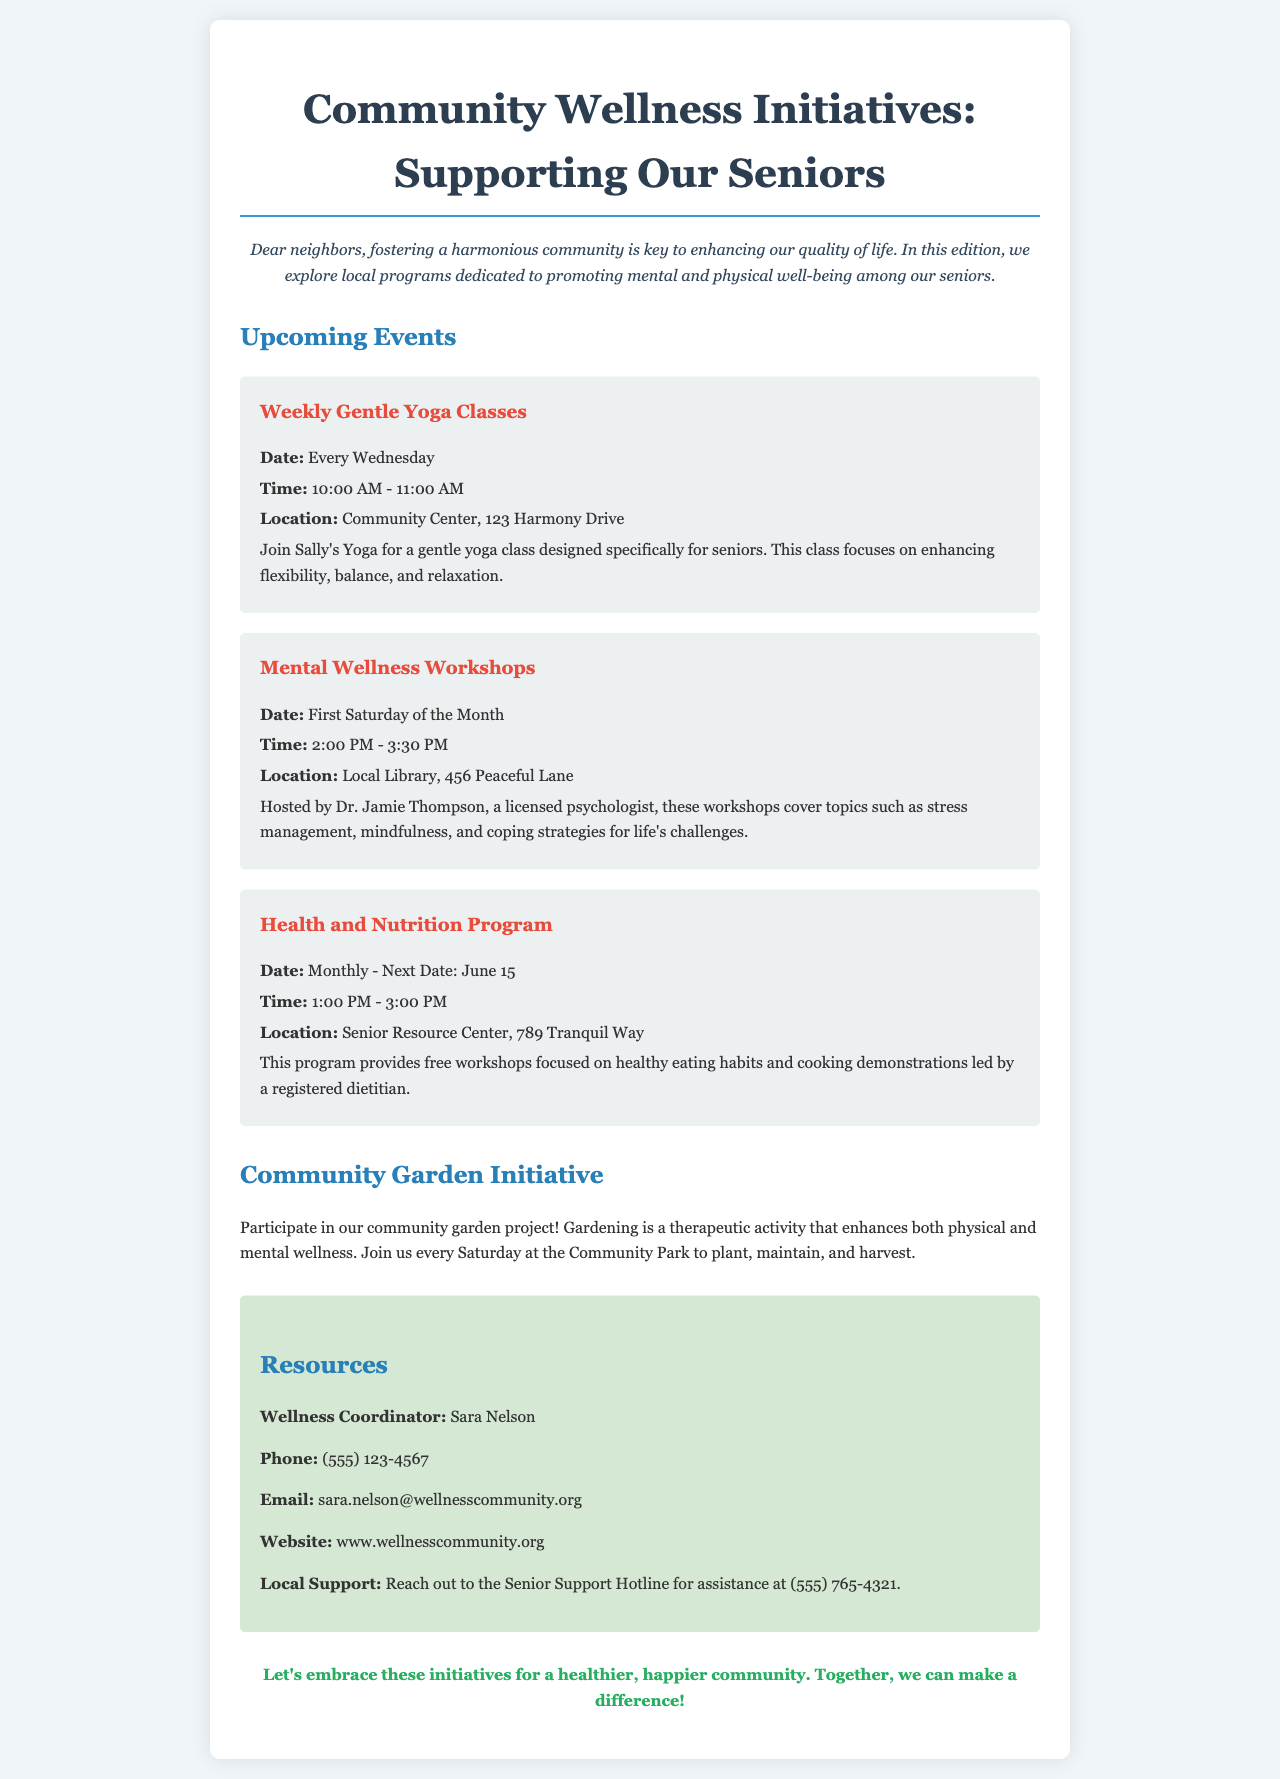What day are the Weekly Gentle Yoga Classes held? The Weekly Gentle Yoga Classes are scheduled every Wednesday, as mentioned in the events section.
Answer: Every Wednesday Who hosts the Mental Wellness Workshops? The Mental Wellness Workshops are hosted by Dr. Jamie Thompson, a licensed psychologist, which is specified in the event details.
Answer: Dr. Jamie Thompson What is the date of the next Health and Nutrition Program? The next Health and Nutrition Program is on June 15, highlighted in the event list.
Answer: June 15 Where is the location of the Community Center? The Community Center is located at 123 Harmony Drive, as stated in the event announcement.
Answer: 123 Harmony Drive What is the purpose of the Community Garden Initiative? The Community Garden Initiative aims to enhance both physical and mental wellness through gardening, mentioned in the relevant section of the document.
Answer: Therapeutic activity What is the contact phone number for the Wellness Coordinator? The contact phone number for the Wellness Coordinator, Sara Nelson, is given as (555) 123-4567 in the resources section.
Answer: (555) 123-4567 Which day of the month are the Mental Wellness Workshops held? The Mental Wellness Workshops occur on the first Saturday of the month, which is specified in the event details.
Answer: First Saturday What type of program is provided at the Senior Resource Center? The program at the Senior Resource Center is focused on healthy eating habits and cooking demonstrations, as mentioned in the Health and Nutrition section.
Answer: Healthy eating habits How often do the yoga classes take place? The yoga classes occur weekly, indicated in the event listing for the Weekly Gentle Yoga Classes.
Answer: Weekly 